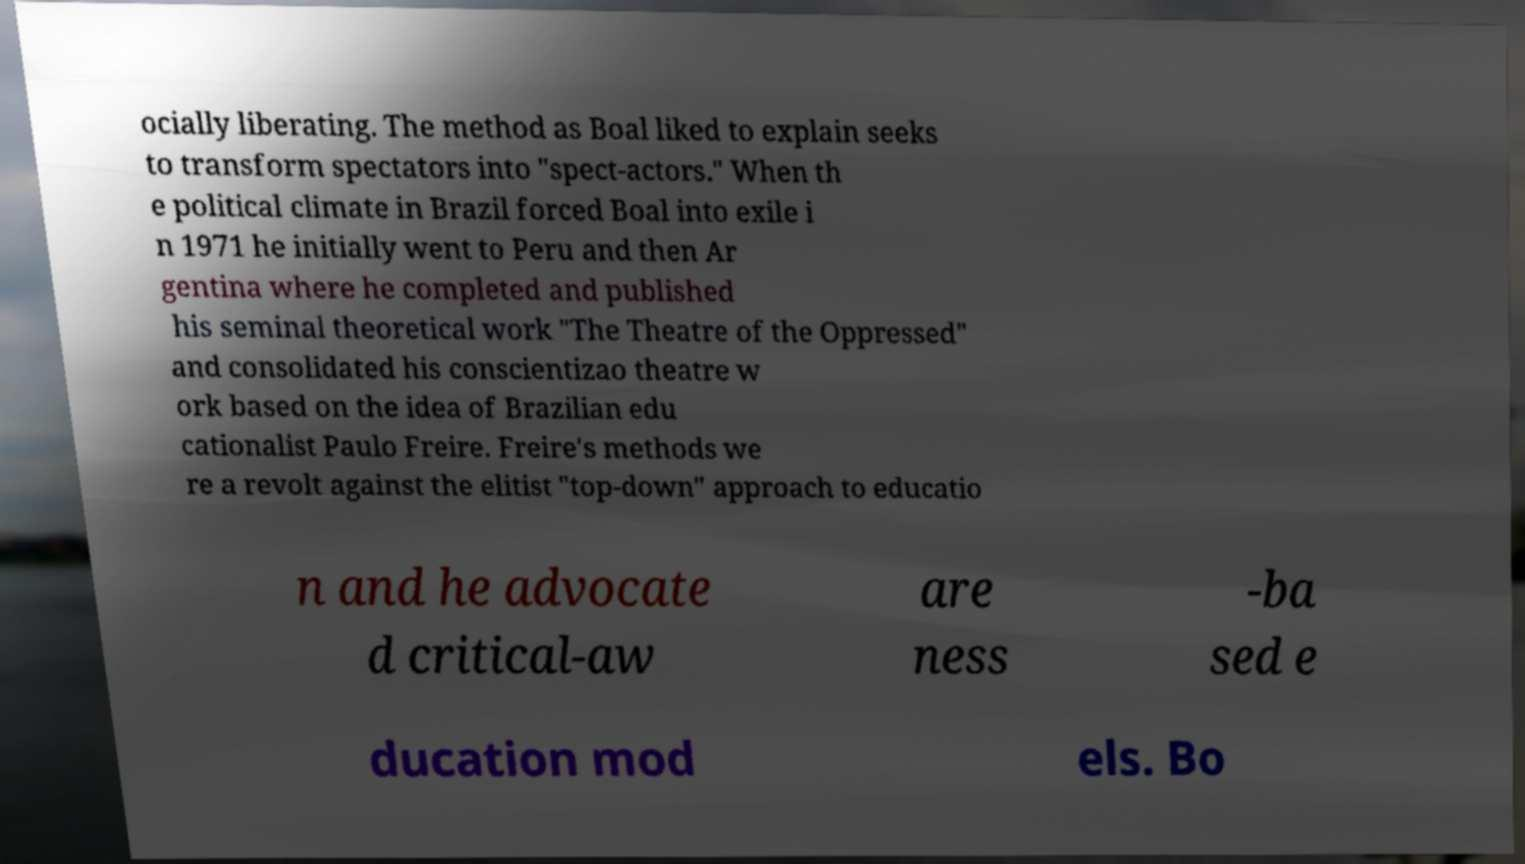For documentation purposes, I need the text within this image transcribed. Could you provide that? ocially liberating. The method as Boal liked to explain seeks to transform spectators into "spect-actors." When th e political climate in Brazil forced Boal into exile i n 1971 he initially went to Peru and then Ar gentina where he completed and published his seminal theoretical work "The Theatre of the Oppressed" and consolidated his conscientizao theatre w ork based on the idea of Brazilian edu cationalist Paulo Freire. Freire's methods we re a revolt against the elitist "top-down" approach to educatio n and he advocate d critical-aw are ness -ba sed e ducation mod els. Bo 